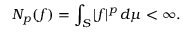Convert formula to latex. <formula><loc_0><loc_0><loc_500><loc_500>N _ { p } ( f ) = \int _ { S } | f | ^ { p } \, d \mu < \infty .</formula> 